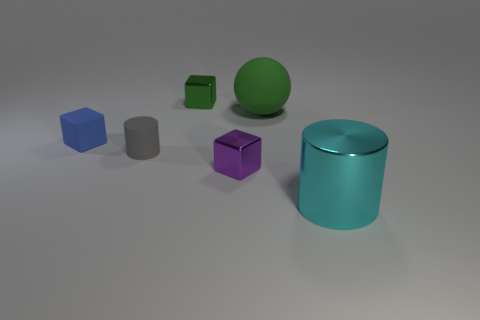What number of small shiny blocks are in front of the tiny block behind the large object behind the large cylinder?
Provide a short and direct response. 1. What number of tiny purple metallic cylinders are there?
Your answer should be compact. 0. Are there fewer blue rubber cubes behind the gray object than shiny things that are right of the green cube?
Make the answer very short. Yes. Is the number of blue matte blocks that are to the right of the gray rubber cylinder less than the number of tiny purple things?
Make the answer very short. Yes. What material is the cube in front of the matte object that is left of the small rubber object that is on the right side of the tiny blue block made of?
Keep it short and to the point. Metal. What number of objects are tiny gray matte things behind the big metal cylinder or tiny things that are left of the purple metal thing?
Give a very brief answer. 3. There is a green object that is the same shape as the tiny blue rubber thing; what material is it?
Give a very brief answer. Metal. How many rubber objects are either tiny gray things or green cubes?
Provide a short and direct response. 1. What shape is the small gray thing that is made of the same material as the big green ball?
Your answer should be compact. Cylinder. What number of blue things are the same shape as the small green object?
Your answer should be very brief. 1. 